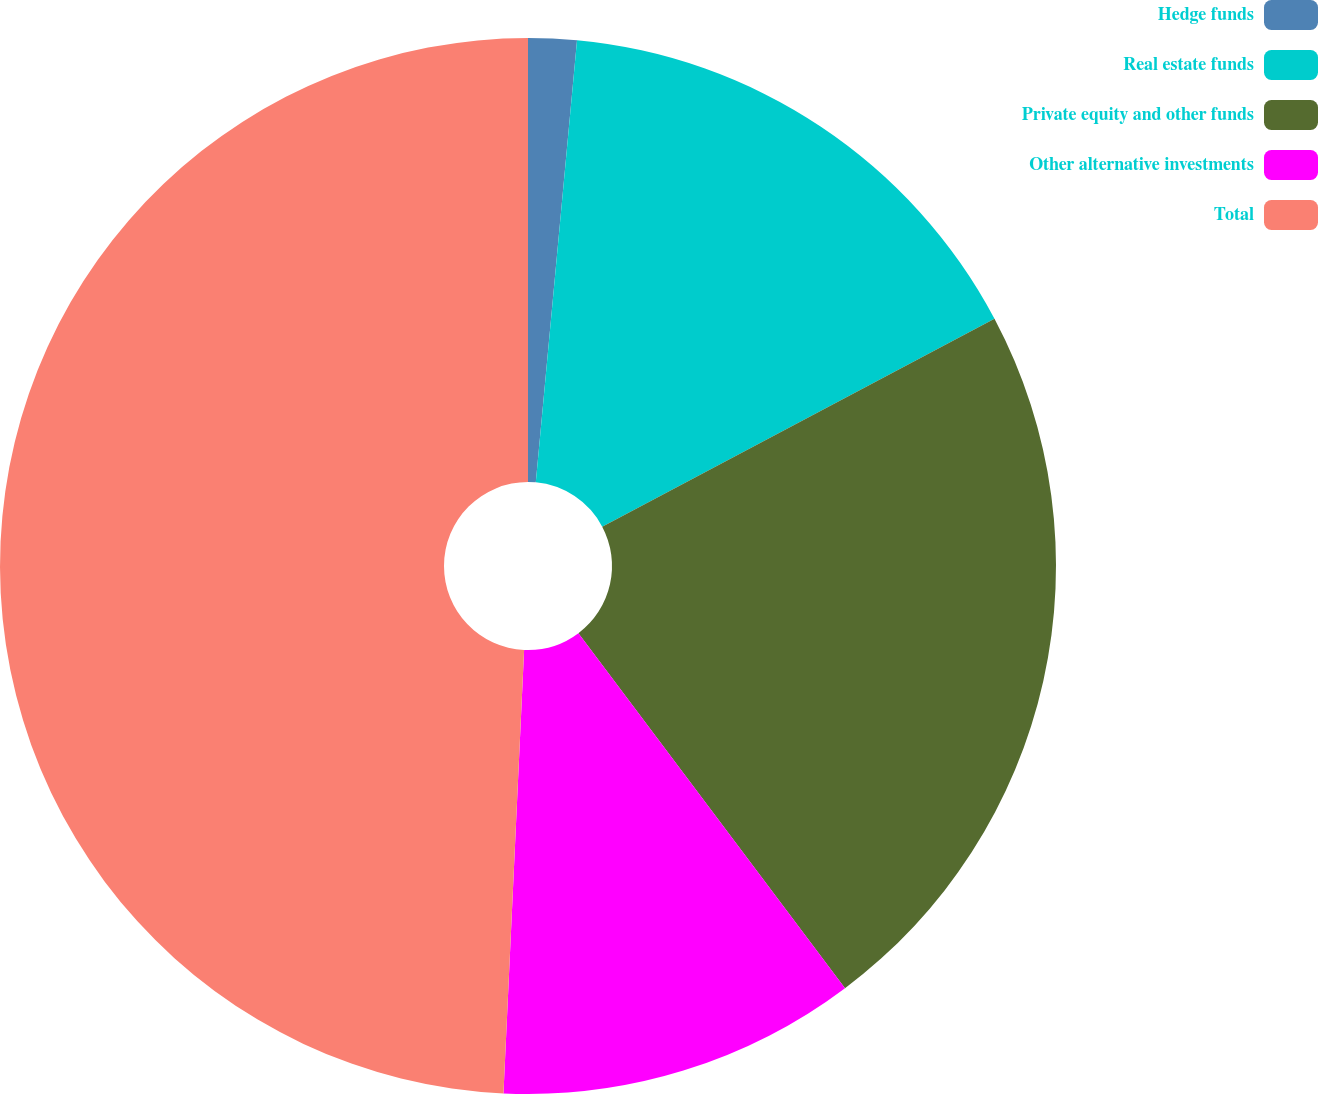Convert chart to OTSL. <chart><loc_0><loc_0><loc_500><loc_500><pie_chart><fcel>Hedge funds<fcel>Real estate funds<fcel>Private equity and other funds<fcel>Other alternative investments<fcel>Total<nl><fcel>1.48%<fcel>15.76%<fcel>22.51%<fcel>10.99%<fcel>49.26%<nl></chart> 